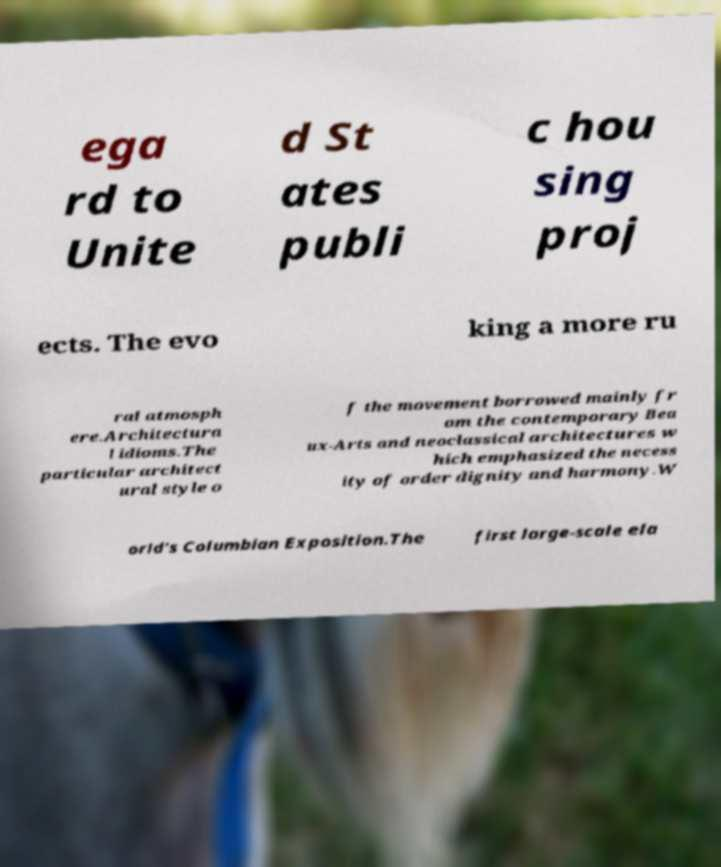I need the written content from this picture converted into text. Can you do that? ega rd to Unite d St ates publi c hou sing proj ects. The evo king a more ru ral atmosph ere.Architectura l idioms.The particular architect ural style o f the movement borrowed mainly fr om the contemporary Bea ux-Arts and neoclassical architectures w hich emphasized the necess ity of order dignity and harmony.W orld's Columbian Exposition.The first large-scale ela 